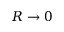Convert formula to latex. <formula><loc_0><loc_0><loc_500><loc_500>R \to 0</formula> 